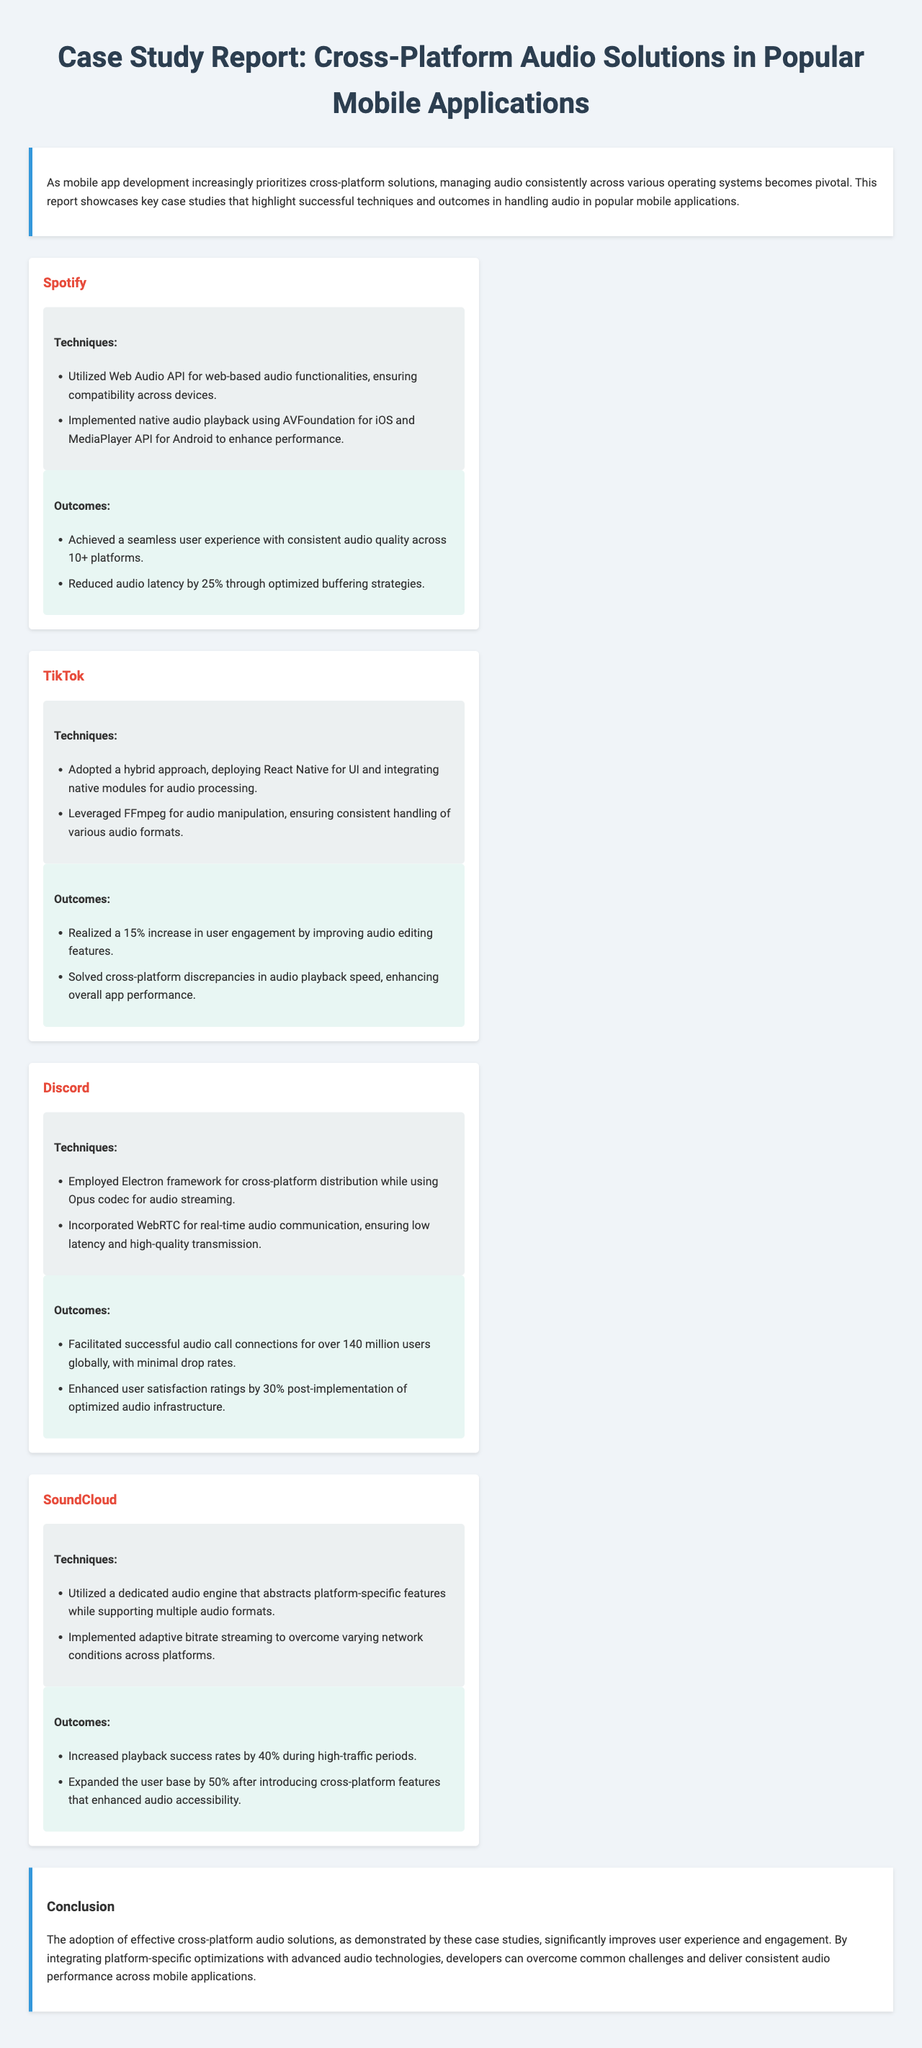What audio technology did Spotify use for web functionality? Spotify used the Web Audio API for web-based audio functionalities.
Answer: Web Audio API Which audio codec does Discord utilize for streaming? Discord incorporated the Opus codec for audio streaming.
Answer: Opus codec How much did SoundCloud increase playback success rates? SoundCloud increased playback success rates by 40% during high-traffic periods.
Answer: 40% What framework did Discord employ for cross-platform distribution? Discord employed the Electron framework for cross-platform distribution.
Answer: Electron What percentage increase in user engagement did TikTok realize? TikTok realized a 15% increase in user engagement.
Answer: 15% What technique did SoundCloud implement to handle varying network conditions? SoundCloud implemented adaptive bitrate streaming.
Answer: Adaptive bitrate streaming What was the outcome of optimizing audio infrastructure for Discord? User satisfaction ratings enhanced by 30% post-implementation.
Answer: 30% How many users globally facilitated successful audio call connections in Discord? Discord facilitated successful audio call connections for over 140 million users.
Answer: 140 million What prevalent issue does the report aim to address? The report addresses managing audio consistently across various operating systems.
Answer: Managing audio consistently across various operating systems 